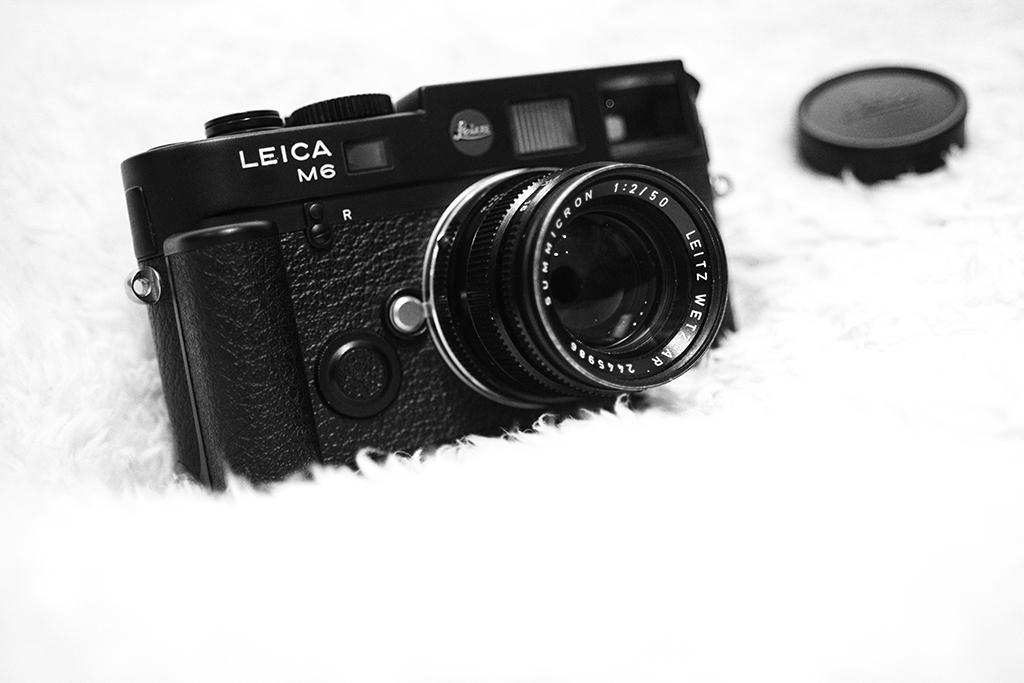What is the main subject in the center of the image? There is a camera in the center of the image. What else can be seen in the image besides the camera? There is a cap placed on the mat. How many birds are perched on the camera in the image? There are no birds present in the image; it only features a camera and a cap on the mat. 